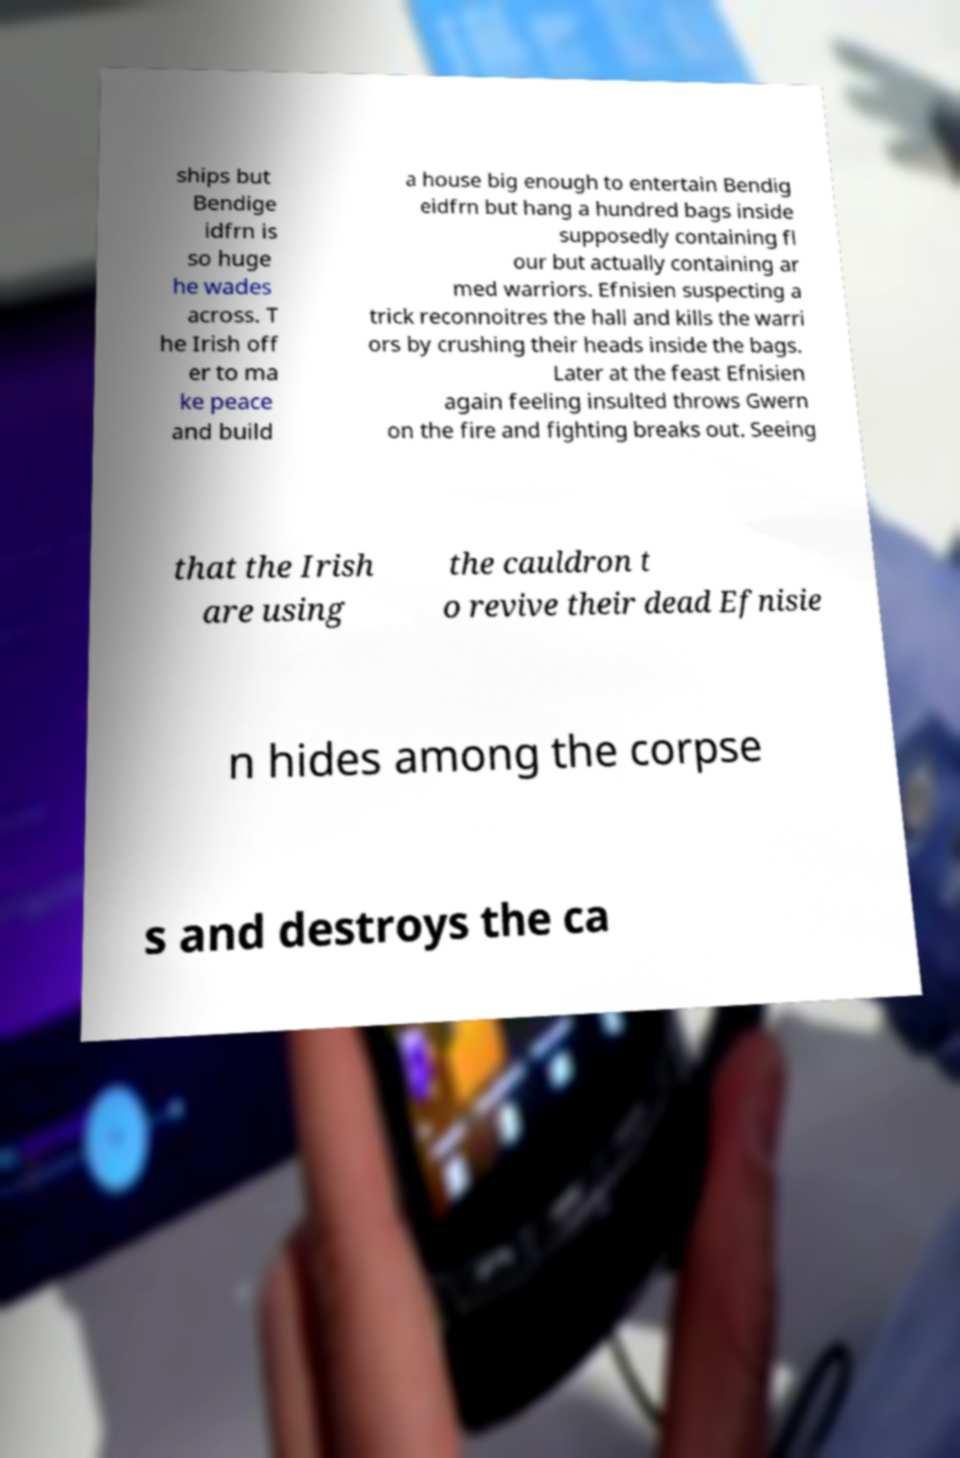Can you read and provide the text displayed in the image?This photo seems to have some interesting text. Can you extract and type it out for me? ships but Bendige idfrn is so huge he wades across. T he Irish off er to ma ke peace and build a house big enough to entertain Bendig eidfrn but hang a hundred bags inside supposedly containing fl our but actually containing ar med warriors. Efnisien suspecting a trick reconnoitres the hall and kills the warri ors by crushing their heads inside the bags. Later at the feast Efnisien again feeling insulted throws Gwern on the fire and fighting breaks out. Seeing that the Irish are using the cauldron t o revive their dead Efnisie n hides among the corpse s and destroys the ca 